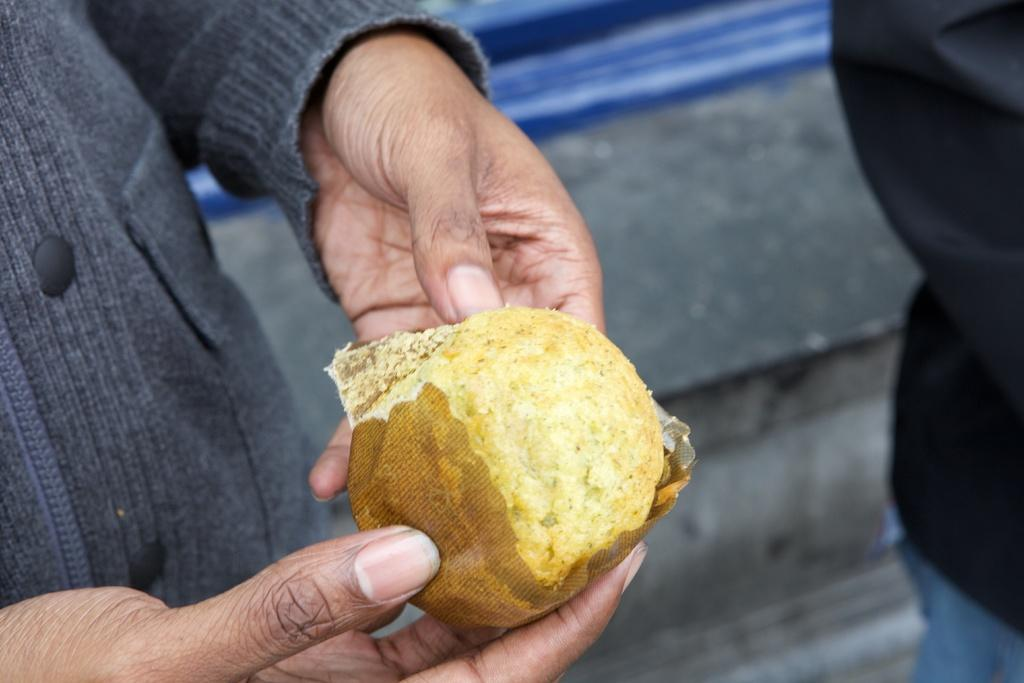What is the main subject of the image? There is a person in the image. What is the person holding in the image? The person is holding a food item. Can you describe the background of the person in the image? The background of the person is blurred. What type of oil can be seen dripping from the person's hair in the image? There is no oil or any dripping substance visible in the person's hair in the image. 